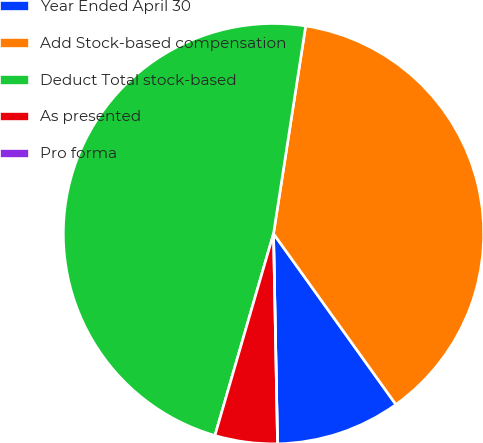<chart> <loc_0><loc_0><loc_500><loc_500><pie_chart><fcel>Year Ended April 30<fcel>Add Stock-based compensation<fcel>Deduct Total stock-based<fcel>As presented<fcel>Pro forma<nl><fcel>9.59%<fcel>37.66%<fcel>47.95%<fcel>4.8%<fcel>0.0%<nl></chart> 